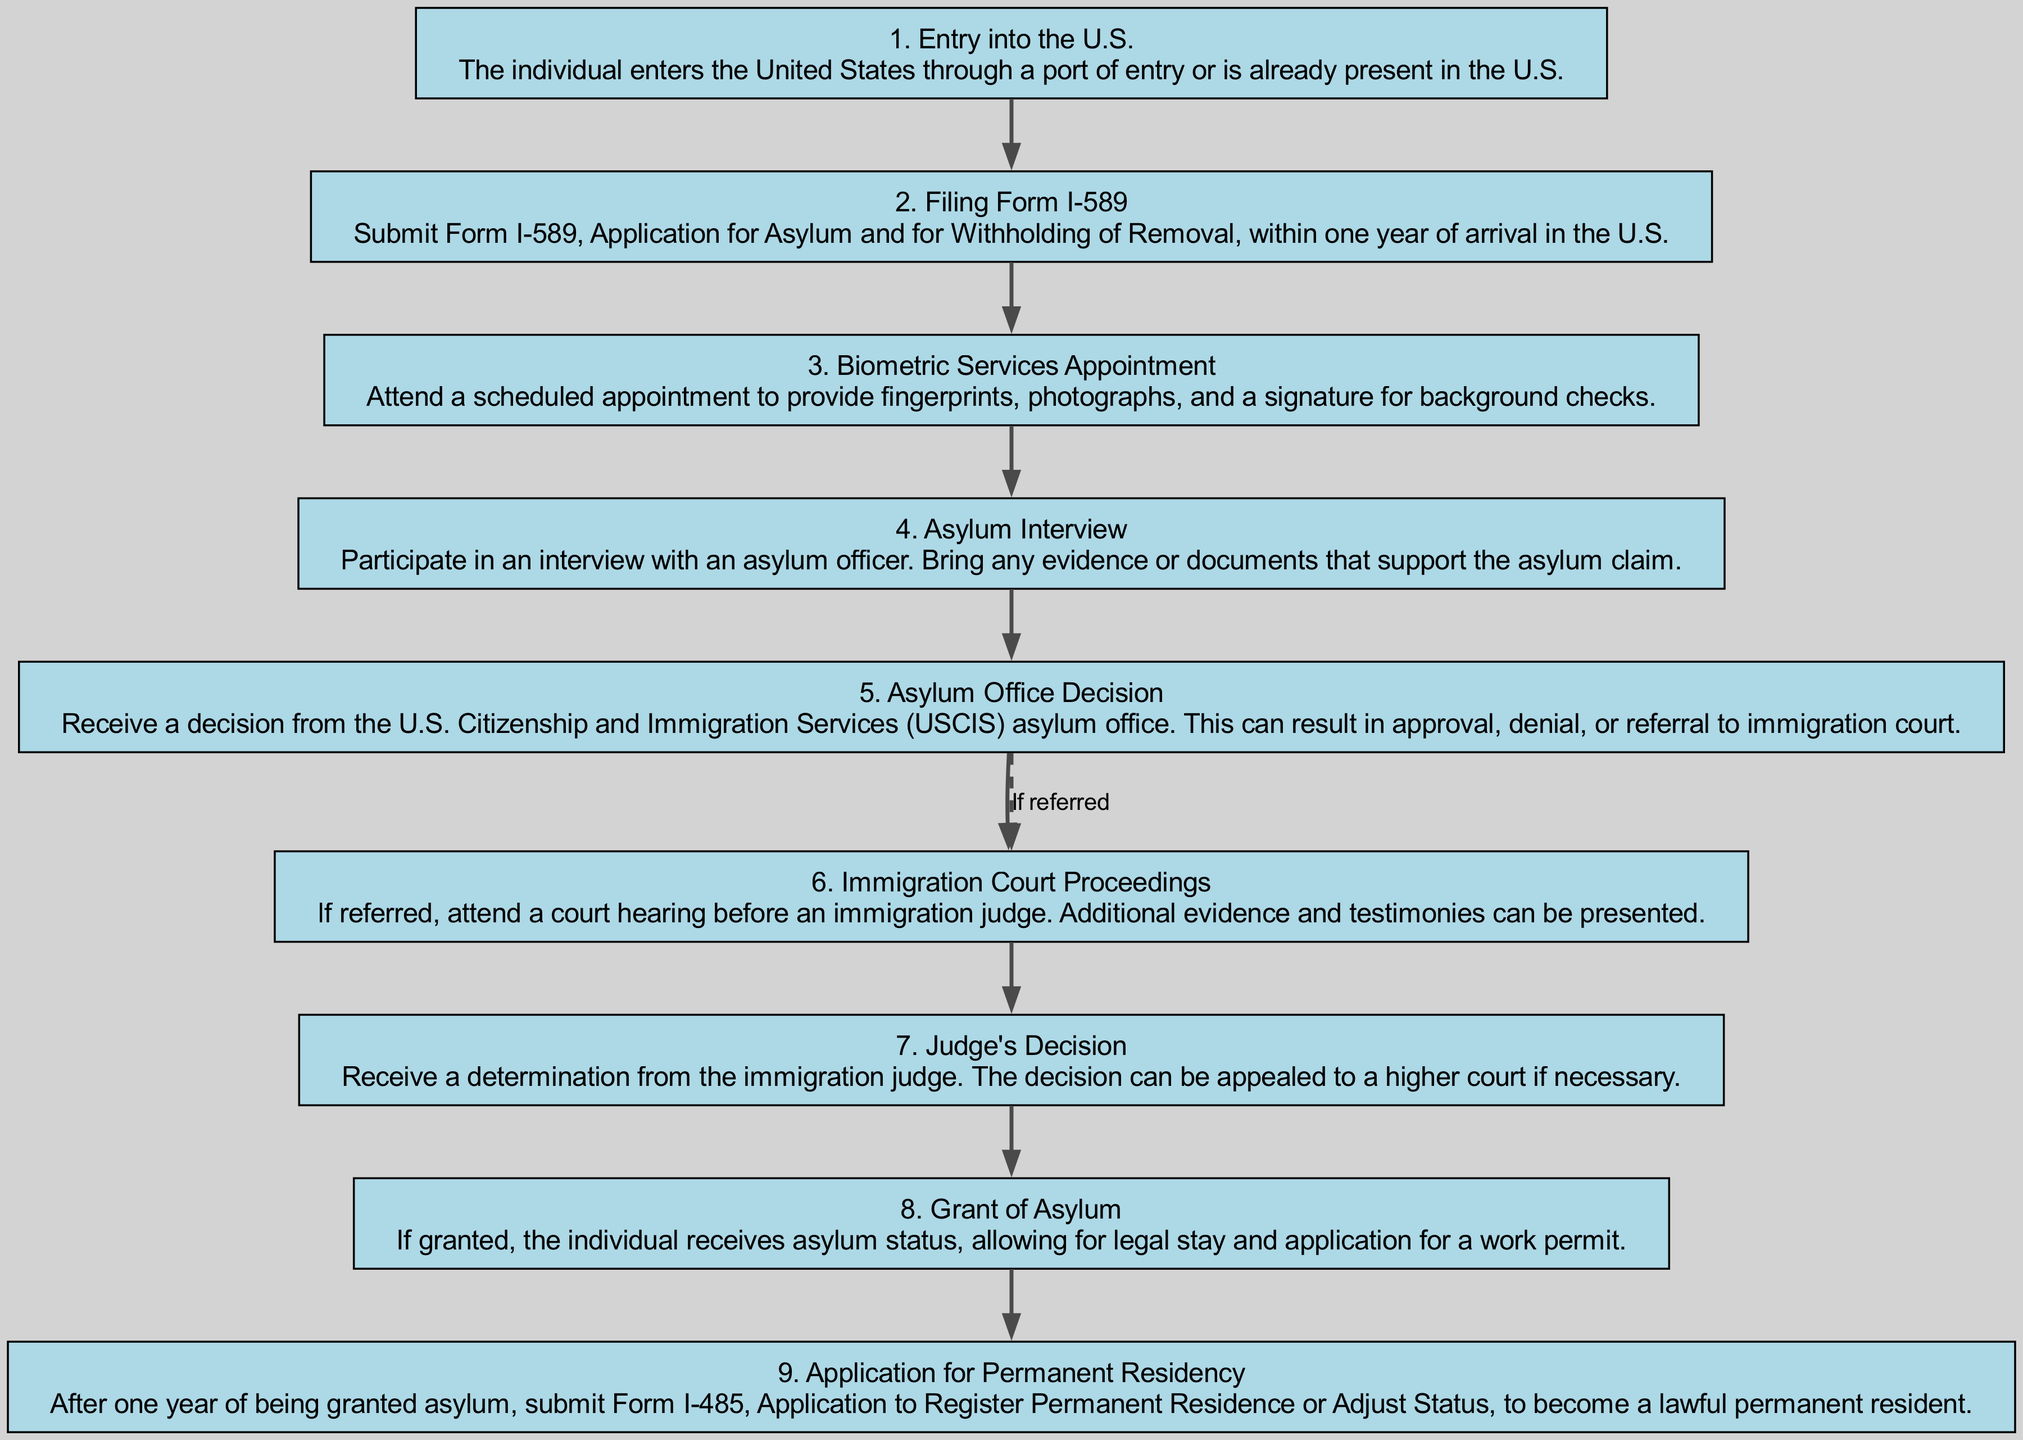What is the first step in the asylum application process? The first step is identified as "Entry into the U.S.," which indicates that the individual must enter the United States through a port of entry or be present in the U.S.
Answer: Entry into the U.S How many steps are there in the asylum application process? By counting the steps listed in the diagram, we can see there are a total of 9 steps from entry to the application for permanent residency.
Answer: 9 What document must be filed after entering the U.S.? The diagram specifies that "Form I-589" must be submitted as the next step after entry into the U.S. for the asylum application.
Answer: Form I-589 What occurs after the asylum interview? According to the flow chart, the next step after the Asylum Interview is receiving a decision from the U.S. Citizenship and Immigration Services (USCIS) asylum office.
Answer: Asylum Office Decision Which step follows the asylum office decision if referred? The diagram indicates that if the asylum office decides to refer the case, the next step is "Immigration Court Proceedings." This is highlighted by the dashed edge showing the conditional flow.
Answer: Immigration Court Proceedings How does the judge's decision affect the asylum process? The judge's decision, as shown in the diagram, determines the outcome of the case and can result in further actions such as an appeal to a higher court. This means the judge's decision is a crucial part of the process.
Answer: It can be appealed What do individuals receive if their asylum application is granted? If granted asylum, the individual receives asylum status, which allows for legal stay and the ability to apply for a work permit, as discerned from the respective diagram step.
Answer: Grant of Asylum What is required for permanent residency application following asylum grant? The flow chart specifies that one must submit "Form I-485" after one year of being granted asylum to apply for permanent residency, indicating a necessary action in the process.
Answer: Form I-485 What is the condition for attending Immigration Court Proceedings? The diagram states that attending Immigration Court Proceedings is dependent on a referral from the asylum office's decision, which is a condition clearly laid out in the flow chart.
Answer: If referred 